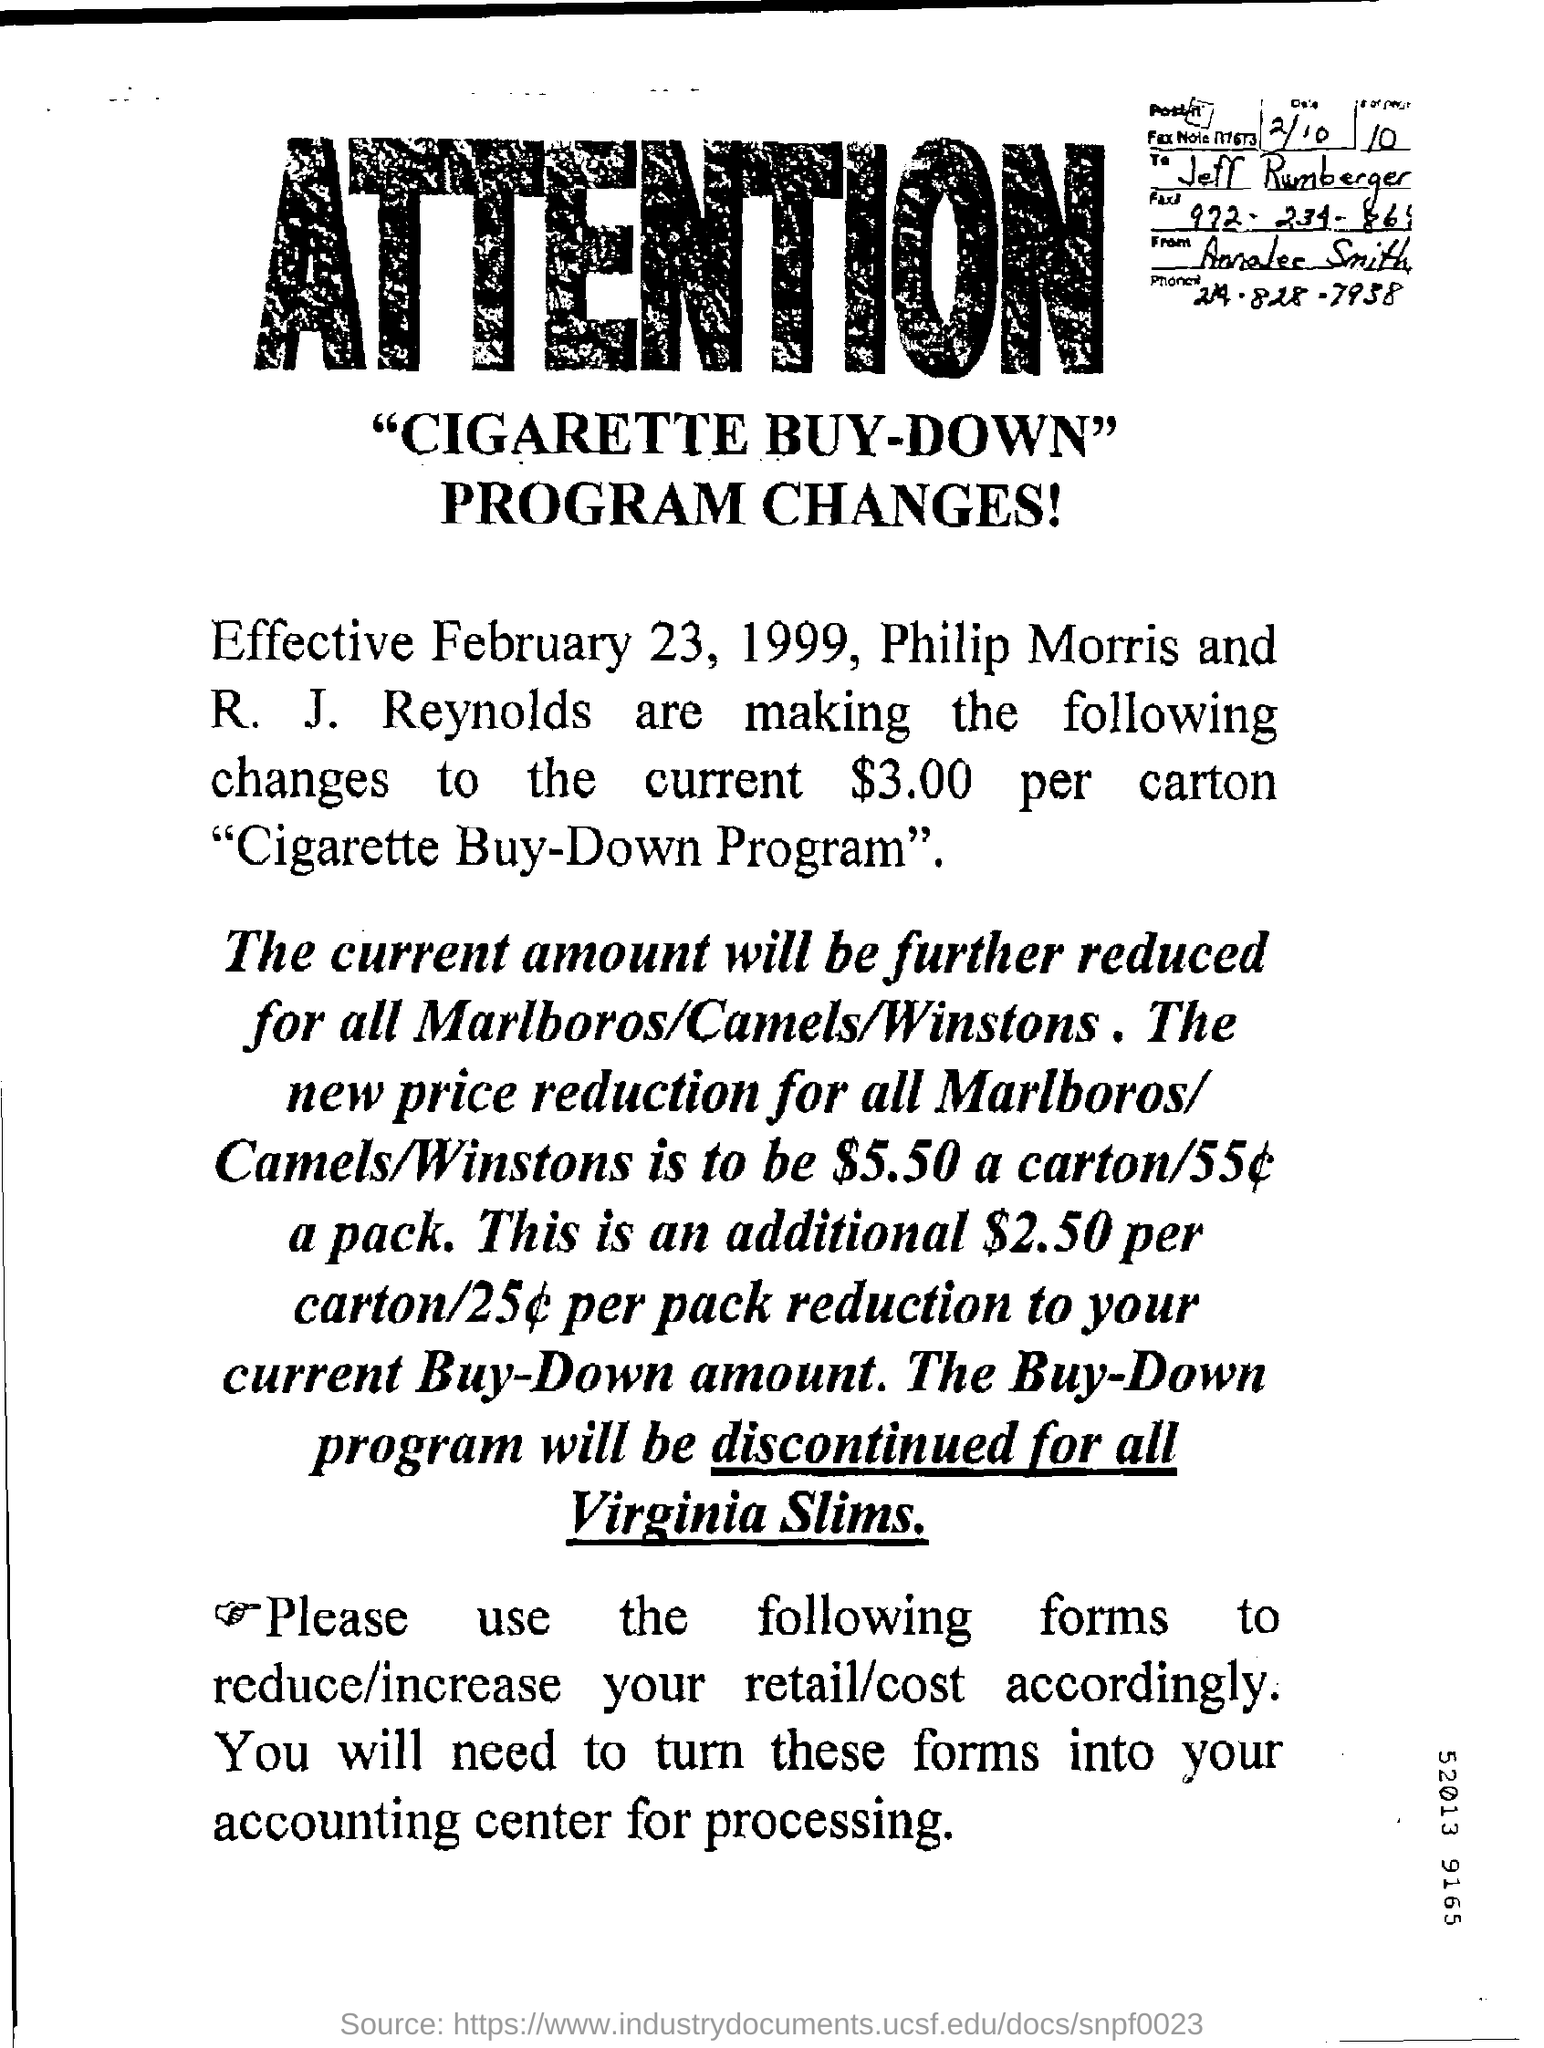When is the program change effective from?
Your answer should be compact. February 23, 1999. Who is the fax note addressed to?
Your answer should be compact. Jeff Rumberger. For which items will the Buy-Down Program be discontinued?
Make the answer very short. All virginia slims. What is the current price per carton?
Provide a short and direct response. $3.00. 